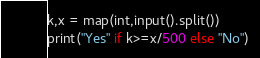<code> <loc_0><loc_0><loc_500><loc_500><_Python_>k,x = map(int,input().split())
print("Yes" if k>=x/500 else "No")</code> 